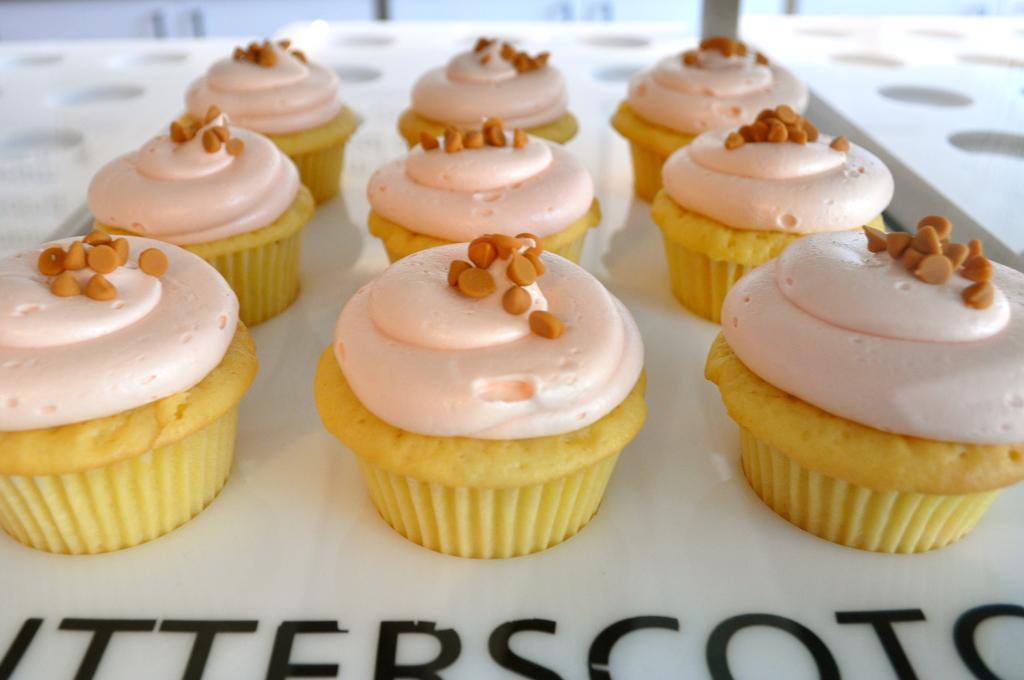Can you describe this image briefly? This picture consists of cookies , on top of cookies cream and chocolates kept and cookies kept on tray and on the tray there is a text written at the bottom and there is another tray visible visible on the right side and on the left side 